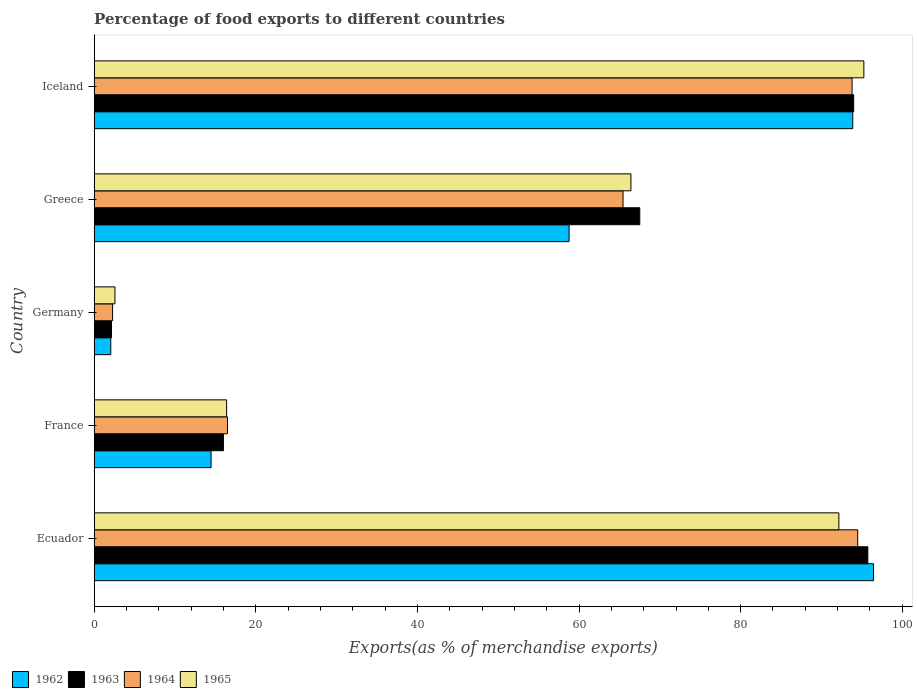How many different coloured bars are there?
Your answer should be compact. 4. Are the number of bars per tick equal to the number of legend labels?
Make the answer very short. Yes. Are the number of bars on each tick of the Y-axis equal?
Your answer should be compact. Yes. How many bars are there on the 3rd tick from the top?
Give a very brief answer. 4. How many bars are there on the 5th tick from the bottom?
Give a very brief answer. 4. What is the percentage of exports to different countries in 1964 in France?
Give a very brief answer. 16.5. Across all countries, what is the maximum percentage of exports to different countries in 1962?
Offer a very short reply. 96.45. Across all countries, what is the minimum percentage of exports to different countries in 1965?
Ensure brevity in your answer.  2.57. In which country was the percentage of exports to different countries in 1962 maximum?
Your answer should be very brief. Ecuador. What is the total percentage of exports to different countries in 1963 in the graph?
Keep it short and to the point. 275.38. What is the difference between the percentage of exports to different countries in 1964 in France and that in Germany?
Offer a terse response. 14.22. What is the difference between the percentage of exports to different countries in 1965 in Iceland and the percentage of exports to different countries in 1962 in Ecuador?
Offer a very short reply. -1.19. What is the average percentage of exports to different countries in 1965 per country?
Give a very brief answer. 54.56. What is the difference between the percentage of exports to different countries in 1962 and percentage of exports to different countries in 1964 in Greece?
Ensure brevity in your answer.  -6.67. What is the ratio of the percentage of exports to different countries in 1963 in France to that in Greece?
Provide a succinct answer. 0.24. Is the percentage of exports to different countries in 1963 in Ecuador less than that in France?
Your answer should be very brief. No. What is the difference between the highest and the second highest percentage of exports to different countries in 1962?
Your answer should be compact. 2.57. What is the difference between the highest and the lowest percentage of exports to different countries in 1962?
Ensure brevity in your answer.  94.39. Is it the case that in every country, the sum of the percentage of exports to different countries in 1964 and percentage of exports to different countries in 1962 is greater than the sum of percentage of exports to different countries in 1965 and percentage of exports to different countries in 1963?
Ensure brevity in your answer.  No. What does the 1st bar from the top in Ecuador represents?
Offer a terse response. 1965. What does the 4th bar from the bottom in Greece represents?
Your answer should be very brief. 1965. Is it the case that in every country, the sum of the percentage of exports to different countries in 1962 and percentage of exports to different countries in 1965 is greater than the percentage of exports to different countries in 1963?
Your answer should be very brief. Yes. How many bars are there?
Make the answer very short. 20. Are all the bars in the graph horizontal?
Keep it short and to the point. Yes. How many countries are there in the graph?
Provide a succinct answer. 5. What is the difference between two consecutive major ticks on the X-axis?
Offer a terse response. 20. Does the graph contain any zero values?
Keep it short and to the point. No. Does the graph contain grids?
Provide a short and direct response. No. Where does the legend appear in the graph?
Provide a short and direct response. Bottom left. What is the title of the graph?
Ensure brevity in your answer.  Percentage of food exports to different countries. What is the label or title of the X-axis?
Your answer should be very brief. Exports(as % of merchandise exports). What is the Exports(as % of merchandise exports) of 1962 in Ecuador?
Provide a succinct answer. 96.45. What is the Exports(as % of merchandise exports) in 1963 in Ecuador?
Your answer should be very brief. 95.74. What is the Exports(as % of merchandise exports) in 1964 in Ecuador?
Keep it short and to the point. 94.49. What is the Exports(as % of merchandise exports) of 1965 in Ecuador?
Provide a succinct answer. 92.15. What is the Exports(as % of merchandise exports) of 1962 in France?
Offer a terse response. 14.46. What is the Exports(as % of merchandise exports) in 1963 in France?
Your response must be concise. 15.99. What is the Exports(as % of merchandise exports) of 1964 in France?
Offer a very short reply. 16.5. What is the Exports(as % of merchandise exports) of 1965 in France?
Your answer should be very brief. 16.38. What is the Exports(as % of merchandise exports) in 1962 in Germany?
Your answer should be compact. 2.05. What is the Exports(as % of merchandise exports) in 1963 in Germany?
Your response must be concise. 2.14. What is the Exports(as % of merchandise exports) in 1964 in Germany?
Keep it short and to the point. 2.27. What is the Exports(as % of merchandise exports) of 1965 in Germany?
Give a very brief answer. 2.57. What is the Exports(as % of merchandise exports) in 1962 in Greece?
Keep it short and to the point. 58.77. What is the Exports(as % of merchandise exports) in 1963 in Greece?
Your response must be concise. 67.52. What is the Exports(as % of merchandise exports) of 1964 in Greece?
Your response must be concise. 65.45. What is the Exports(as % of merchandise exports) of 1965 in Greece?
Your answer should be compact. 66.42. What is the Exports(as % of merchandise exports) of 1962 in Iceland?
Offer a very short reply. 93.87. What is the Exports(as % of merchandise exports) of 1963 in Iceland?
Your answer should be very brief. 93.99. What is the Exports(as % of merchandise exports) in 1964 in Iceland?
Provide a short and direct response. 93.79. What is the Exports(as % of merchandise exports) of 1965 in Iceland?
Offer a terse response. 95.25. Across all countries, what is the maximum Exports(as % of merchandise exports) of 1962?
Keep it short and to the point. 96.45. Across all countries, what is the maximum Exports(as % of merchandise exports) in 1963?
Offer a very short reply. 95.74. Across all countries, what is the maximum Exports(as % of merchandise exports) of 1964?
Keep it short and to the point. 94.49. Across all countries, what is the maximum Exports(as % of merchandise exports) of 1965?
Offer a very short reply. 95.25. Across all countries, what is the minimum Exports(as % of merchandise exports) of 1962?
Your response must be concise. 2.05. Across all countries, what is the minimum Exports(as % of merchandise exports) in 1963?
Offer a terse response. 2.14. Across all countries, what is the minimum Exports(as % of merchandise exports) in 1964?
Provide a short and direct response. 2.27. Across all countries, what is the minimum Exports(as % of merchandise exports) in 1965?
Make the answer very short. 2.57. What is the total Exports(as % of merchandise exports) of 1962 in the graph?
Keep it short and to the point. 265.61. What is the total Exports(as % of merchandise exports) in 1963 in the graph?
Your answer should be very brief. 275.38. What is the total Exports(as % of merchandise exports) of 1964 in the graph?
Keep it short and to the point. 272.49. What is the total Exports(as % of merchandise exports) of 1965 in the graph?
Keep it short and to the point. 272.78. What is the difference between the Exports(as % of merchandise exports) in 1962 in Ecuador and that in France?
Offer a very short reply. 81.98. What is the difference between the Exports(as % of merchandise exports) in 1963 in Ecuador and that in France?
Your answer should be compact. 79.75. What is the difference between the Exports(as % of merchandise exports) of 1964 in Ecuador and that in France?
Provide a short and direct response. 77.99. What is the difference between the Exports(as % of merchandise exports) in 1965 in Ecuador and that in France?
Offer a terse response. 75.77. What is the difference between the Exports(as % of merchandise exports) of 1962 in Ecuador and that in Germany?
Your response must be concise. 94.39. What is the difference between the Exports(as % of merchandise exports) in 1963 in Ecuador and that in Germany?
Offer a terse response. 93.6. What is the difference between the Exports(as % of merchandise exports) in 1964 in Ecuador and that in Germany?
Keep it short and to the point. 92.21. What is the difference between the Exports(as % of merchandise exports) of 1965 in Ecuador and that in Germany?
Make the answer very short. 89.59. What is the difference between the Exports(as % of merchandise exports) of 1962 in Ecuador and that in Greece?
Your answer should be compact. 37.67. What is the difference between the Exports(as % of merchandise exports) in 1963 in Ecuador and that in Greece?
Keep it short and to the point. 28.22. What is the difference between the Exports(as % of merchandise exports) of 1964 in Ecuador and that in Greece?
Provide a short and direct response. 29.04. What is the difference between the Exports(as % of merchandise exports) of 1965 in Ecuador and that in Greece?
Provide a short and direct response. 25.73. What is the difference between the Exports(as % of merchandise exports) of 1962 in Ecuador and that in Iceland?
Make the answer very short. 2.57. What is the difference between the Exports(as % of merchandise exports) in 1963 in Ecuador and that in Iceland?
Your answer should be compact. 1.75. What is the difference between the Exports(as % of merchandise exports) in 1964 in Ecuador and that in Iceland?
Your response must be concise. 0.7. What is the difference between the Exports(as % of merchandise exports) of 1965 in Ecuador and that in Iceland?
Make the answer very short. -3.1. What is the difference between the Exports(as % of merchandise exports) in 1962 in France and that in Germany?
Provide a short and direct response. 12.41. What is the difference between the Exports(as % of merchandise exports) in 1963 in France and that in Germany?
Your answer should be compact. 13.85. What is the difference between the Exports(as % of merchandise exports) in 1964 in France and that in Germany?
Offer a very short reply. 14.22. What is the difference between the Exports(as % of merchandise exports) of 1965 in France and that in Germany?
Make the answer very short. 13.82. What is the difference between the Exports(as % of merchandise exports) in 1962 in France and that in Greece?
Your answer should be compact. -44.31. What is the difference between the Exports(as % of merchandise exports) of 1963 in France and that in Greece?
Your answer should be compact. -51.53. What is the difference between the Exports(as % of merchandise exports) in 1964 in France and that in Greece?
Provide a short and direct response. -48.95. What is the difference between the Exports(as % of merchandise exports) in 1965 in France and that in Greece?
Keep it short and to the point. -50.04. What is the difference between the Exports(as % of merchandise exports) in 1962 in France and that in Iceland?
Keep it short and to the point. -79.41. What is the difference between the Exports(as % of merchandise exports) of 1963 in France and that in Iceland?
Offer a terse response. -78. What is the difference between the Exports(as % of merchandise exports) of 1964 in France and that in Iceland?
Give a very brief answer. -77.29. What is the difference between the Exports(as % of merchandise exports) of 1965 in France and that in Iceland?
Keep it short and to the point. -78.87. What is the difference between the Exports(as % of merchandise exports) of 1962 in Germany and that in Greece?
Offer a terse response. -56.72. What is the difference between the Exports(as % of merchandise exports) in 1963 in Germany and that in Greece?
Keep it short and to the point. -65.38. What is the difference between the Exports(as % of merchandise exports) in 1964 in Germany and that in Greece?
Your answer should be compact. -63.17. What is the difference between the Exports(as % of merchandise exports) of 1965 in Germany and that in Greece?
Offer a very short reply. -63.85. What is the difference between the Exports(as % of merchandise exports) of 1962 in Germany and that in Iceland?
Your answer should be compact. -91.82. What is the difference between the Exports(as % of merchandise exports) of 1963 in Germany and that in Iceland?
Ensure brevity in your answer.  -91.85. What is the difference between the Exports(as % of merchandise exports) in 1964 in Germany and that in Iceland?
Provide a short and direct response. -91.52. What is the difference between the Exports(as % of merchandise exports) in 1965 in Germany and that in Iceland?
Make the answer very short. -92.68. What is the difference between the Exports(as % of merchandise exports) of 1962 in Greece and that in Iceland?
Make the answer very short. -35.1. What is the difference between the Exports(as % of merchandise exports) in 1963 in Greece and that in Iceland?
Offer a terse response. -26.47. What is the difference between the Exports(as % of merchandise exports) in 1964 in Greece and that in Iceland?
Make the answer very short. -28.35. What is the difference between the Exports(as % of merchandise exports) in 1965 in Greece and that in Iceland?
Your answer should be very brief. -28.83. What is the difference between the Exports(as % of merchandise exports) of 1962 in Ecuador and the Exports(as % of merchandise exports) of 1963 in France?
Offer a terse response. 80.45. What is the difference between the Exports(as % of merchandise exports) in 1962 in Ecuador and the Exports(as % of merchandise exports) in 1964 in France?
Your answer should be very brief. 79.95. What is the difference between the Exports(as % of merchandise exports) in 1962 in Ecuador and the Exports(as % of merchandise exports) in 1965 in France?
Provide a short and direct response. 80.06. What is the difference between the Exports(as % of merchandise exports) of 1963 in Ecuador and the Exports(as % of merchandise exports) of 1964 in France?
Offer a terse response. 79.24. What is the difference between the Exports(as % of merchandise exports) of 1963 in Ecuador and the Exports(as % of merchandise exports) of 1965 in France?
Provide a succinct answer. 79.36. What is the difference between the Exports(as % of merchandise exports) of 1964 in Ecuador and the Exports(as % of merchandise exports) of 1965 in France?
Ensure brevity in your answer.  78.1. What is the difference between the Exports(as % of merchandise exports) of 1962 in Ecuador and the Exports(as % of merchandise exports) of 1963 in Germany?
Keep it short and to the point. 94.31. What is the difference between the Exports(as % of merchandise exports) of 1962 in Ecuador and the Exports(as % of merchandise exports) of 1964 in Germany?
Your answer should be very brief. 94.17. What is the difference between the Exports(as % of merchandise exports) in 1962 in Ecuador and the Exports(as % of merchandise exports) in 1965 in Germany?
Keep it short and to the point. 93.88. What is the difference between the Exports(as % of merchandise exports) in 1963 in Ecuador and the Exports(as % of merchandise exports) in 1964 in Germany?
Give a very brief answer. 93.46. What is the difference between the Exports(as % of merchandise exports) in 1963 in Ecuador and the Exports(as % of merchandise exports) in 1965 in Germany?
Make the answer very short. 93.17. What is the difference between the Exports(as % of merchandise exports) in 1964 in Ecuador and the Exports(as % of merchandise exports) in 1965 in Germany?
Keep it short and to the point. 91.92. What is the difference between the Exports(as % of merchandise exports) in 1962 in Ecuador and the Exports(as % of merchandise exports) in 1963 in Greece?
Your response must be concise. 28.93. What is the difference between the Exports(as % of merchandise exports) of 1962 in Ecuador and the Exports(as % of merchandise exports) of 1964 in Greece?
Your answer should be compact. 31. What is the difference between the Exports(as % of merchandise exports) of 1962 in Ecuador and the Exports(as % of merchandise exports) of 1965 in Greece?
Your response must be concise. 30.02. What is the difference between the Exports(as % of merchandise exports) of 1963 in Ecuador and the Exports(as % of merchandise exports) of 1964 in Greece?
Ensure brevity in your answer.  30.29. What is the difference between the Exports(as % of merchandise exports) in 1963 in Ecuador and the Exports(as % of merchandise exports) in 1965 in Greece?
Provide a short and direct response. 29.32. What is the difference between the Exports(as % of merchandise exports) of 1964 in Ecuador and the Exports(as % of merchandise exports) of 1965 in Greece?
Offer a terse response. 28.07. What is the difference between the Exports(as % of merchandise exports) in 1962 in Ecuador and the Exports(as % of merchandise exports) in 1963 in Iceland?
Offer a terse response. 2.45. What is the difference between the Exports(as % of merchandise exports) of 1962 in Ecuador and the Exports(as % of merchandise exports) of 1964 in Iceland?
Offer a terse response. 2.65. What is the difference between the Exports(as % of merchandise exports) of 1962 in Ecuador and the Exports(as % of merchandise exports) of 1965 in Iceland?
Keep it short and to the point. 1.2. What is the difference between the Exports(as % of merchandise exports) of 1963 in Ecuador and the Exports(as % of merchandise exports) of 1964 in Iceland?
Give a very brief answer. 1.95. What is the difference between the Exports(as % of merchandise exports) in 1963 in Ecuador and the Exports(as % of merchandise exports) in 1965 in Iceland?
Ensure brevity in your answer.  0.49. What is the difference between the Exports(as % of merchandise exports) in 1964 in Ecuador and the Exports(as % of merchandise exports) in 1965 in Iceland?
Your answer should be compact. -0.76. What is the difference between the Exports(as % of merchandise exports) in 1962 in France and the Exports(as % of merchandise exports) in 1963 in Germany?
Give a very brief answer. 12.32. What is the difference between the Exports(as % of merchandise exports) of 1962 in France and the Exports(as % of merchandise exports) of 1964 in Germany?
Your response must be concise. 12.19. What is the difference between the Exports(as % of merchandise exports) in 1962 in France and the Exports(as % of merchandise exports) in 1965 in Germany?
Your answer should be very brief. 11.9. What is the difference between the Exports(as % of merchandise exports) in 1963 in France and the Exports(as % of merchandise exports) in 1964 in Germany?
Make the answer very short. 13.72. What is the difference between the Exports(as % of merchandise exports) in 1963 in France and the Exports(as % of merchandise exports) in 1965 in Germany?
Offer a very short reply. 13.42. What is the difference between the Exports(as % of merchandise exports) of 1964 in France and the Exports(as % of merchandise exports) of 1965 in Germany?
Provide a succinct answer. 13.93. What is the difference between the Exports(as % of merchandise exports) in 1962 in France and the Exports(as % of merchandise exports) in 1963 in Greece?
Provide a short and direct response. -53.05. What is the difference between the Exports(as % of merchandise exports) of 1962 in France and the Exports(as % of merchandise exports) of 1964 in Greece?
Keep it short and to the point. -50.98. What is the difference between the Exports(as % of merchandise exports) of 1962 in France and the Exports(as % of merchandise exports) of 1965 in Greece?
Make the answer very short. -51.96. What is the difference between the Exports(as % of merchandise exports) in 1963 in France and the Exports(as % of merchandise exports) in 1964 in Greece?
Keep it short and to the point. -49.45. What is the difference between the Exports(as % of merchandise exports) of 1963 in France and the Exports(as % of merchandise exports) of 1965 in Greece?
Ensure brevity in your answer.  -50.43. What is the difference between the Exports(as % of merchandise exports) in 1964 in France and the Exports(as % of merchandise exports) in 1965 in Greece?
Give a very brief answer. -49.93. What is the difference between the Exports(as % of merchandise exports) in 1962 in France and the Exports(as % of merchandise exports) in 1963 in Iceland?
Provide a succinct answer. -79.53. What is the difference between the Exports(as % of merchandise exports) of 1962 in France and the Exports(as % of merchandise exports) of 1964 in Iceland?
Ensure brevity in your answer.  -79.33. What is the difference between the Exports(as % of merchandise exports) of 1962 in France and the Exports(as % of merchandise exports) of 1965 in Iceland?
Offer a terse response. -80.79. What is the difference between the Exports(as % of merchandise exports) in 1963 in France and the Exports(as % of merchandise exports) in 1964 in Iceland?
Your response must be concise. -77.8. What is the difference between the Exports(as % of merchandise exports) of 1963 in France and the Exports(as % of merchandise exports) of 1965 in Iceland?
Provide a short and direct response. -79.26. What is the difference between the Exports(as % of merchandise exports) of 1964 in France and the Exports(as % of merchandise exports) of 1965 in Iceland?
Provide a short and direct response. -78.75. What is the difference between the Exports(as % of merchandise exports) in 1962 in Germany and the Exports(as % of merchandise exports) in 1963 in Greece?
Your answer should be compact. -65.47. What is the difference between the Exports(as % of merchandise exports) of 1962 in Germany and the Exports(as % of merchandise exports) of 1964 in Greece?
Offer a terse response. -63.39. What is the difference between the Exports(as % of merchandise exports) of 1962 in Germany and the Exports(as % of merchandise exports) of 1965 in Greece?
Keep it short and to the point. -64.37. What is the difference between the Exports(as % of merchandise exports) of 1963 in Germany and the Exports(as % of merchandise exports) of 1964 in Greece?
Your response must be concise. -63.31. What is the difference between the Exports(as % of merchandise exports) of 1963 in Germany and the Exports(as % of merchandise exports) of 1965 in Greece?
Provide a short and direct response. -64.28. What is the difference between the Exports(as % of merchandise exports) in 1964 in Germany and the Exports(as % of merchandise exports) in 1965 in Greece?
Provide a short and direct response. -64.15. What is the difference between the Exports(as % of merchandise exports) in 1962 in Germany and the Exports(as % of merchandise exports) in 1963 in Iceland?
Offer a terse response. -91.94. What is the difference between the Exports(as % of merchandise exports) in 1962 in Germany and the Exports(as % of merchandise exports) in 1964 in Iceland?
Provide a short and direct response. -91.74. What is the difference between the Exports(as % of merchandise exports) of 1962 in Germany and the Exports(as % of merchandise exports) of 1965 in Iceland?
Offer a terse response. -93.2. What is the difference between the Exports(as % of merchandise exports) of 1963 in Germany and the Exports(as % of merchandise exports) of 1964 in Iceland?
Your response must be concise. -91.65. What is the difference between the Exports(as % of merchandise exports) in 1963 in Germany and the Exports(as % of merchandise exports) in 1965 in Iceland?
Your answer should be very brief. -93.11. What is the difference between the Exports(as % of merchandise exports) of 1964 in Germany and the Exports(as % of merchandise exports) of 1965 in Iceland?
Your answer should be compact. -92.98. What is the difference between the Exports(as % of merchandise exports) of 1962 in Greece and the Exports(as % of merchandise exports) of 1963 in Iceland?
Provide a succinct answer. -35.22. What is the difference between the Exports(as % of merchandise exports) in 1962 in Greece and the Exports(as % of merchandise exports) in 1964 in Iceland?
Provide a short and direct response. -35.02. What is the difference between the Exports(as % of merchandise exports) in 1962 in Greece and the Exports(as % of merchandise exports) in 1965 in Iceland?
Offer a terse response. -36.48. What is the difference between the Exports(as % of merchandise exports) of 1963 in Greece and the Exports(as % of merchandise exports) of 1964 in Iceland?
Offer a very short reply. -26.27. What is the difference between the Exports(as % of merchandise exports) of 1963 in Greece and the Exports(as % of merchandise exports) of 1965 in Iceland?
Keep it short and to the point. -27.73. What is the difference between the Exports(as % of merchandise exports) in 1964 in Greece and the Exports(as % of merchandise exports) in 1965 in Iceland?
Provide a short and direct response. -29.8. What is the average Exports(as % of merchandise exports) of 1962 per country?
Your answer should be very brief. 53.12. What is the average Exports(as % of merchandise exports) of 1963 per country?
Your response must be concise. 55.08. What is the average Exports(as % of merchandise exports) in 1964 per country?
Your answer should be very brief. 54.5. What is the average Exports(as % of merchandise exports) of 1965 per country?
Offer a terse response. 54.56. What is the difference between the Exports(as % of merchandise exports) in 1962 and Exports(as % of merchandise exports) in 1963 in Ecuador?
Provide a succinct answer. 0.71. What is the difference between the Exports(as % of merchandise exports) of 1962 and Exports(as % of merchandise exports) of 1964 in Ecuador?
Provide a short and direct response. 1.96. What is the difference between the Exports(as % of merchandise exports) in 1962 and Exports(as % of merchandise exports) in 1965 in Ecuador?
Your answer should be very brief. 4.29. What is the difference between the Exports(as % of merchandise exports) in 1963 and Exports(as % of merchandise exports) in 1964 in Ecuador?
Offer a terse response. 1.25. What is the difference between the Exports(as % of merchandise exports) in 1963 and Exports(as % of merchandise exports) in 1965 in Ecuador?
Offer a very short reply. 3.58. What is the difference between the Exports(as % of merchandise exports) of 1964 and Exports(as % of merchandise exports) of 1965 in Ecuador?
Your answer should be compact. 2.33. What is the difference between the Exports(as % of merchandise exports) of 1962 and Exports(as % of merchandise exports) of 1963 in France?
Provide a short and direct response. -1.53. What is the difference between the Exports(as % of merchandise exports) of 1962 and Exports(as % of merchandise exports) of 1964 in France?
Offer a very short reply. -2.03. What is the difference between the Exports(as % of merchandise exports) in 1962 and Exports(as % of merchandise exports) in 1965 in France?
Offer a terse response. -1.92. What is the difference between the Exports(as % of merchandise exports) in 1963 and Exports(as % of merchandise exports) in 1964 in France?
Your answer should be compact. -0.5. What is the difference between the Exports(as % of merchandise exports) of 1963 and Exports(as % of merchandise exports) of 1965 in France?
Offer a terse response. -0.39. What is the difference between the Exports(as % of merchandise exports) in 1964 and Exports(as % of merchandise exports) in 1965 in France?
Make the answer very short. 0.11. What is the difference between the Exports(as % of merchandise exports) in 1962 and Exports(as % of merchandise exports) in 1963 in Germany?
Ensure brevity in your answer.  -0.09. What is the difference between the Exports(as % of merchandise exports) in 1962 and Exports(as % of merchandise exports) in 1964 in Germany?
Make the answer very short. -0.22. What is the difference between the Exports(as % of merchandise exports) of 1962 and Exports(as % of merchandise exports) of 1965 in Germany?
Provide a succinct answer. -0.52. What is the difference between the Exports(as % of merchandise exports) of 1963 and Exports(as % of merchandise exports) of 1964 in Germany?
Make the answer very short. -0.14. What is the difference between the Exports(as % of merchandise exports) of 1963 and Exports(as % of merchandise exports) of 1965 in Germany?
Your response must be concise. -0.43. What is the difference between the Exports(as % of merchandise exports) of 1964 and Exports(as % of merchandise exports) of 1965 in Germany?
Offer a terse response. -0.29. What is the difference between the Exports(as % of merchandise exports) in 1962 and Exports(as % of merchandise exports) in 1963 in Greece?
Your answer should be compact. -8.75. What is the difference between the Exports(as % of merchandise exports) in 1962 and Exports(as % of merchandise exports) in 1964 in Greece?
Offer a terse response. -6.67. What is the difference between the Exports(as % of merchandise exports) of 1962 and Exports(as % of merchandise exports) of 1965 in Greece?
Your response must be concise. -7.65. What is the difference between the Exports(as % of merchandise exports) of 1963 and Exports(as % of merchandise exports) of 1964 in Greece?
Your answer should be compact. 2.07. What is the difference between the Exports(as % of merchandise exports) in 1963 and Exports(as % of merchandise exports) in 1965 in Greece?
Your answer should be compact. 1.1. What is the difference between the Exports(as % of merchandise exports) in 1964 and Exports(as % of merchandise exports) in 1965 in Greece?
Offer a very short reply. -0.98. What is the difference between the Exports(as % of merchandise exports) in 1962 and Exports(as % of merchandise exports) in 1963 in Iceland?
Give a very brief answer. -0.12. What is the difference between the Exports(as % of merchandise exports) in 1962 and Exports(as % of merchandise exports) in 1964 in Iceland?
Ensure brevity in your answer.  0.08. What is the difference between the Exports(as % of merchandise exports) in 1962 and Exports(as % of merchandise exports) in 1965 in Iceland?
Provide a succinct answer. -1.38. What is the difference between the Exports(as % of merchandise exports) in 1963 and Exports(as % of merchandise exports) in 1965 in Iceland?
Provide a short and direct response. -1.26. What is the difference between the Exports(as % of merchandise exports) of 1964 and Exports(as % of merchandise exports) of 1965 in Iceland?
Your answer should be very brief. -1.46. What is the ratio of the Exports(as % of merchandise exports) of 1962 in Ecuador to that in France?
Ensure brevity in your answer.  6.67. What is the ratio of the Exports(as % of merchandise exports) of 1963 in Ecuador to that in France?
Make the answer very short. 5.99. What is the ratio of the Exports(as % of merchandise exports) in 1964 in Ecuador to that in France?
Your answer should be compact. 5.73. What is the ratio of the Exports(as % of merchandise exports) of 1965 in Ecuador to that in France?
Provide a succinct answer. 5.62. What is the ratio of the Exports(as % of merchandise exports) in 1962 in Ecuador to that in Germany?
Provide a succinct answer. 47.01. What is the ratio of the Exports(as % of merchandise exports) of 1963 in Ecuador to that in Germany?
Give a very brief answer. 44.76. What is the ratio of the Exports(as % of merchandise exports) in 1964 in Ecuador to that in Germany?
Ensure brevity in your answer.  41.54. What is the ratio of the Exports(as % of merchandise exports) of 1965 in Ecuador to that in Germany?
Your response must be concise. 35.89. What is the ratio of the Exports(as % of merchandise exports) of 1962 in Ecuador to that in Greece?
Keep it short and to the point. 1.64. What is the ratio of the Exports(as % of merchandise exports) of 1963 in Ecuador to that in Greece?
Keep it short and to the point. 1.42. What is the ratio of the Exports(as % of merchandise exports) in 1964 in Ecuador to that in Greece?
Keep it short and to the point. 1.44. What is the ratio of the Exports(as % of merchandise exports) in 1965 in Ecuador to that in Greece?
Offer a very short reply. 1.39. What is the ratio of the Exports(as % of merchandise exports) in 1962 in Ecuador to that in Iceland?
Your answer should be very brief. 1.03. What is the ratio of the Exports(as % of merchandise exports) in 1963 in Ecuador to that in Iceland?
Your response must be concise. 1.02. What is the ratio of the Exports(as % of merchandise exports) of 1964 in Ecuador to that in Iceland?
Make the answer very short. 1.01. What is the ratio of the Exports(as % of merchandise exports) in 1965 in Ecuador to that in Iceland?
Provide a succinct answer. 0.97. What is the ratio of the Exports(as % of merchandise exports) in 1962 in France to that in Germany?
Give a very brief answer. 7.05. What is the ratio of the Exports(as % of merchandise exports) in 1963 in France to that in Germany?
Your answer should be very brief. 7.48. What is the ratio of the Exports(as % of merchandise exports) of 1964 in France to that in Germany?
Give a very brief answer. 7.25. What is the ratio of the Exports(as % of merchandise exports) in 1965 in France to that in Germany?
Provide a short and direct response. 6.38. What is the ratio of the Exports(as % of merchandise exports) of 1962 in France to that in Greece?
Offer a very short reply. 0.25. What is the ratio of the Exports(as % of merchandise exports) in 1963 in France to that in Greece?
Provide a short and direct response. 0.24. What is the ratio of the Exports(as % of merchandise exports) in 1964 in France to that in Greece?
Your response must be concise. 0.25. What is the ratio of the Exports(as % of merchandise exports) in 1965 in France to that in Greece?
Make the answer very short. 0.25. What is the ratio of the Exports(as % of merchandise exports) of 1962 in France to that in Iceland?
Your response must be concise. 0.15. What is the ratio of the Exports(as % of merchandise exports) in 1963 in France to that in Iceland?
Your answer should be compact. 0.17. What is the ratio of the Exports(as % of merchandise exports) of 1964 in France to that in Iceland?
Ensure brevity in your answer.  0.18. What is the ratio of the Exports(as % of merchandise exports) of 1965 in France to that in Iceland?
Provide a short and direct response. 0.17. What is the ratio of the Exports(as % of merchandise exports) in 1962 in Germany to that in Greece?
Your answer should be very brief. 0.03. What is the ratio of the Exports(as % of merchandise exports) in 1963 in Germany to that in Greece?
Make the answer very short. 0.03. What is the ratio of the Exports(as % of merchandise exports) of 1964 in Germany to that in Greece?
Offer a very short reply. 0.03. What is the ratio of the Exports(as % of merchandise exports) of 1965 in Germany to that in Greece?
Keep it short and to the point. 0.04. What is the ratio of the Exports(as % of merchandise exports) in 1962 in Germany to that in Iceland?
Offer a terse response. 0.02. What is the ratio of the Exports(as % of merchandise exports) in 1963 in Germany to that in Iceland?
Give a very brief answer. 0.02. What is the ratio of the Exports(as % of merchandise exports) in 1964 in Germany to that in Iceland?
Give a very brief answer. 0.02. What is the ratio of the Exports(as % of merchandise exports) in 1965 in Germany to that in Iceland?
Your answer should be compact. 0.03. What is the ratio of the Exports(as % of merchandise exports) of 1962 in Greece to that in Iceland?
Your response must be concise. 0.63. What is the ratio of the Exports(as % of merchandise exports) of 1963 in Greece to that in Iceland?
Your answer should be very brief. 0.72. What is the ratio of the Exports(as % of merchandise exports) in 1964 in Greece to that in Iceland?
Your answer should be compact. 0.7. What is the ratio of the Exports(as % of merchandise exports) in 1965 in Greece to that in Iceland?
Ensure brevity in your answer.  0.7. What is the difference between the highest and the second highest Exports(as % of merchandise exports) in 1962?
Provide a short and direct response. 2.57. What is the difference between the highest and the second highest Exports(as % of merchandise exports) of 1963?
Offer a very short reply. 1.75. What is the difference between the highest and the second highest Exports(as % of merchandise exports) in 1964?
Offer a terse response. 0.7. What is the difference between the highest and the second highest Exports(as % of merchandise exports) of 1965?
Keep it short and to the point. 3.1. What is the difference between the highest and the lowest Exports(as % of merchandise exports) of 1962?
Ensure brevity in your answer.  94.39. What is the difference between the highest and the lowest Exports(as % of merchandise exports) of 1963?
Your answer should be very brief. 93.6. What is the difference between the highest and the lowest Exports(as % of merchandise exports) in 1964?
Ensure brevity in your answer.  92.21. What is the difference between the highest and the lowest Exports(as % of merchandise exports) of 1965?
Offer a terse response. 92.68. 